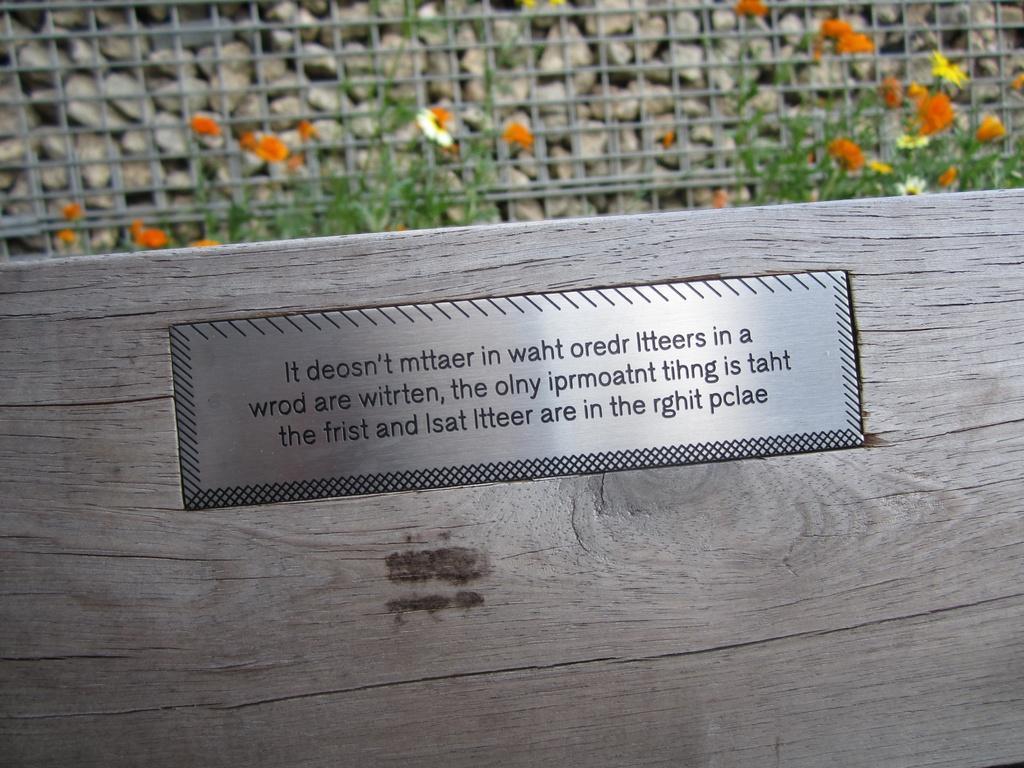In one or two sentences, can you explain what this image depicts? In the front of the image I can see a wooden wall. To that wooden wall there is a board. Something is written on the board. In the background of the image there is a mesh, rocks and flower plants.   